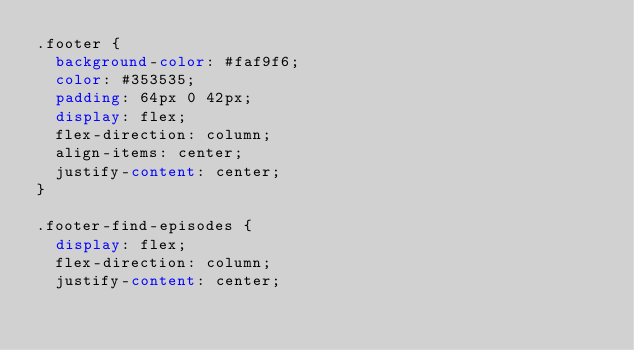<code> <loc_0><loc_0><loc_500><loc_500><_CSS_>.footer {
  background-color: #faf9f6;
  color: #353535;
  padding: 64px 0 42px;
  display: flex;
  flex-direction: column;
  align-items: center;
  justify-content: center;
}

.footer-find-episodes {
  display: flex;
  flex-direction: column;
  justify-content: center;</code> 